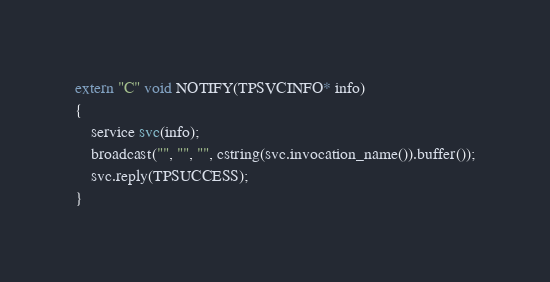Convert code to text. <code><loc_0><loc_0><loc_500><loc_500><_C++_>extern "C" void NOTIFY(TPSVCINFO* info)
{
	service svc(info);
	broadcast("", "", "", cstring(svc.invocation_name()).buffer());
	svc.reply(TPSUCCESS);
}
</code> 